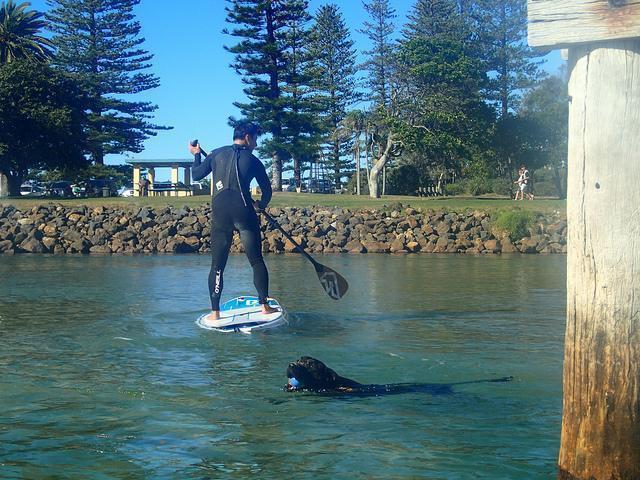What will the dog do with the ball?
Indicate the correct response by choosing from the four available options to answer the question.
Options: Give human, break it, chase it, swallow it. Give human. 